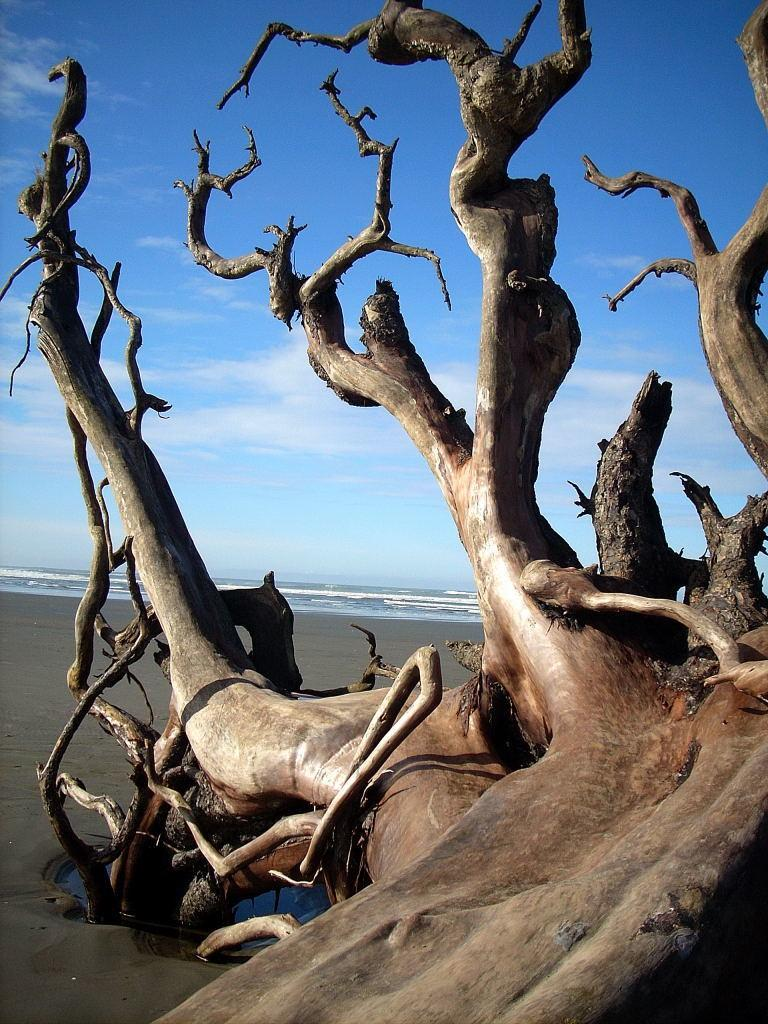What type of plant can be seen in the image? There is a tree in the image. What part of the tree is visible? The bark of the tree is visible. What features are present on the tree? There are branches on the tree. Where is the tree located? The tree is located on the seashore. What can be seen in the background of the image? There is a water body and the sky visible in the background of the image. How would you describe the sky in the image? The sky appears cloudy in the image. Can you see any cobwebs on the tree in the image? There is no mention of cobwebs in the image, so we cannot determine if any are present. What type of metal is used to construct the tree in the image? The tree is a natural plant and not made of metal; it is a living organism. 